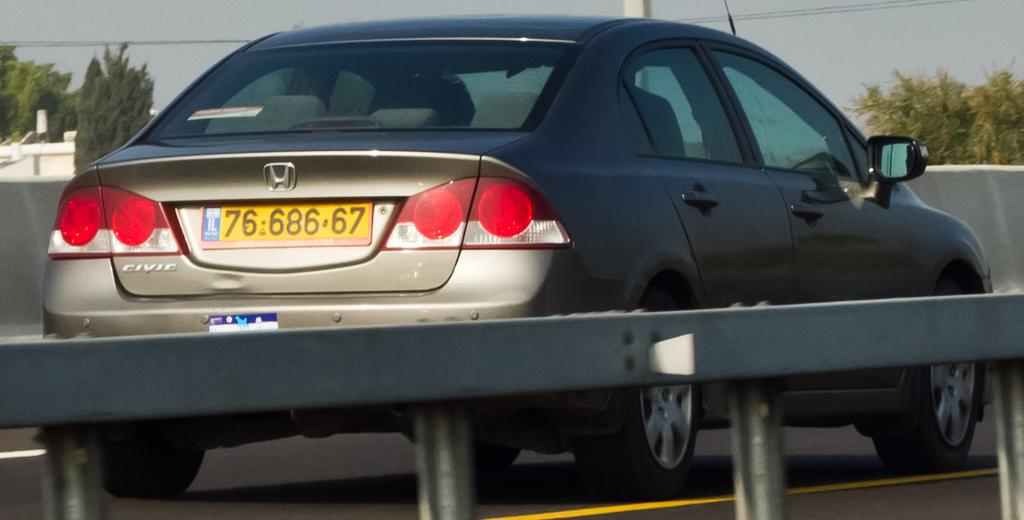<image>
Create a compact narrative representing the image presented. Back view of a Honda car on the road with a European license. 